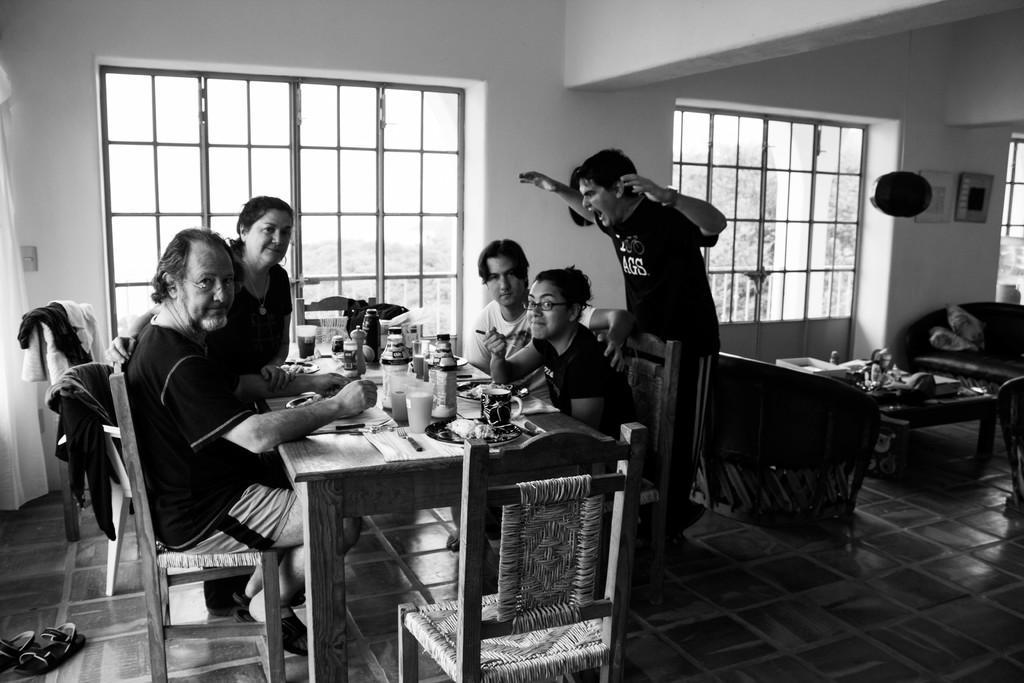Describe this image in one or two sentences. In this picture there are five people. On the left side there is one man sitting beside that man one woman is standing in front of her one man is sitting beside that man one woman is sitting and eating something and she is holding a spoon. In the middle of the image there is one man standing and screaming. On the top of the image there are two windows. On the right side there are two couches and one table and the couch has two pillows. On the table there are two glasses one cup one fork and bottles on it. On the left side there are a pair of shoes. 